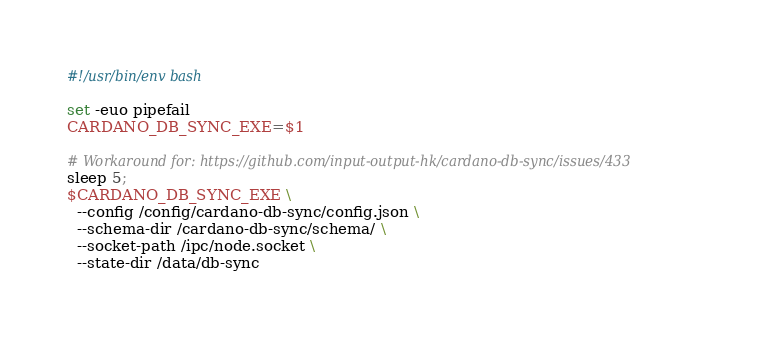<code> <loc_0><loc_0><loc_500><loc_500><_Bash_>#!/usr/bin/env bash

set -euo pipefail
CARDANO_DB_SYNC_EXE=$1

# Workaround for: https://github.com/input-output-hk/cardano-db-sync/issues/433
sleep 5;
$CARDANO_DB_SYNC_EXE \
  --config /config/cardano-db-sync/config.json \
  --schema-dir /cardano-db-sync/schema/ \
  --socket-path /ipc/node.socket \
  --state-dir /data/db-sync
</code> 